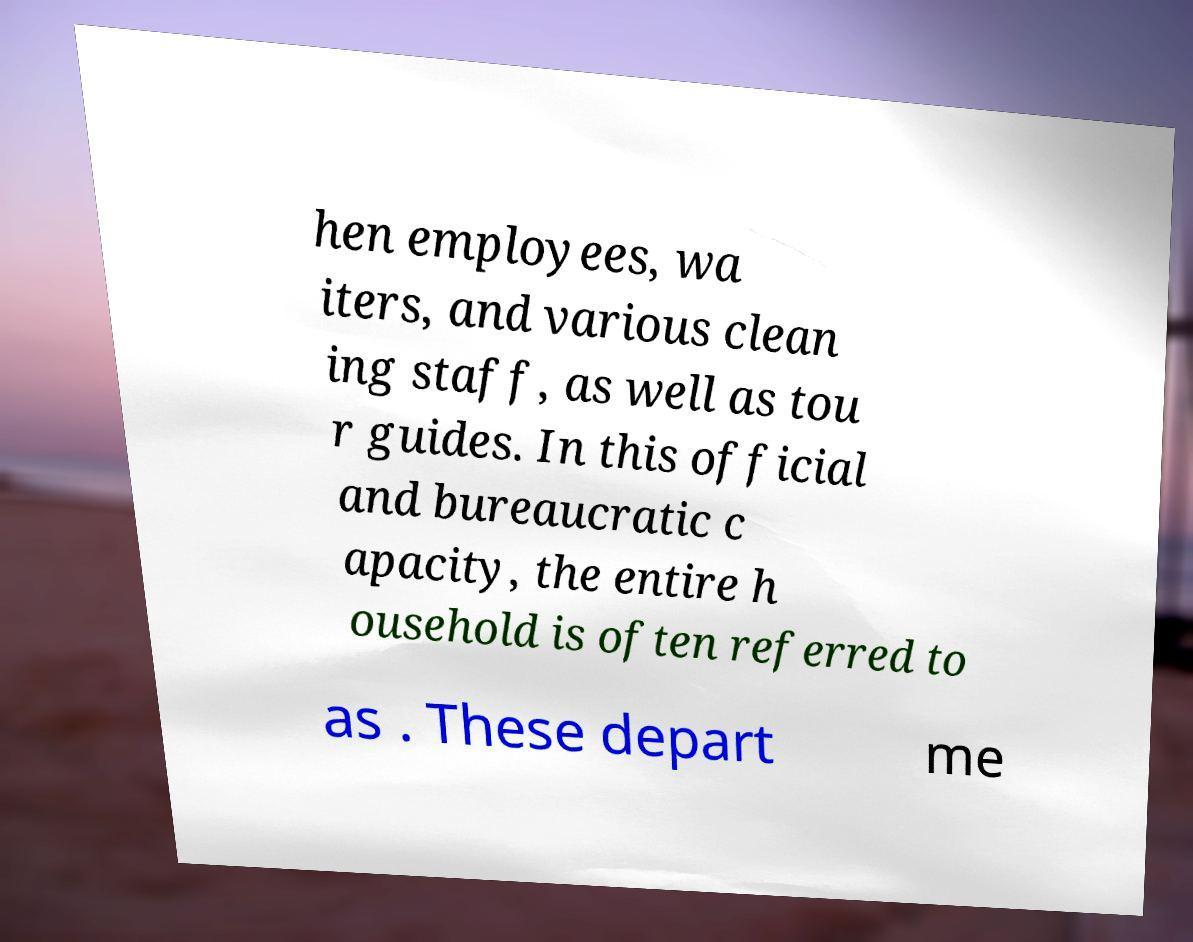For documentation purposes, I need the text within this image transcribed. Could you provide that? hen employees, wa iters, and various clean ing staff, as well as tou r guides. In this official and bureaucratic c apacity, the entire h ousehold is often referred to as . These depart me 